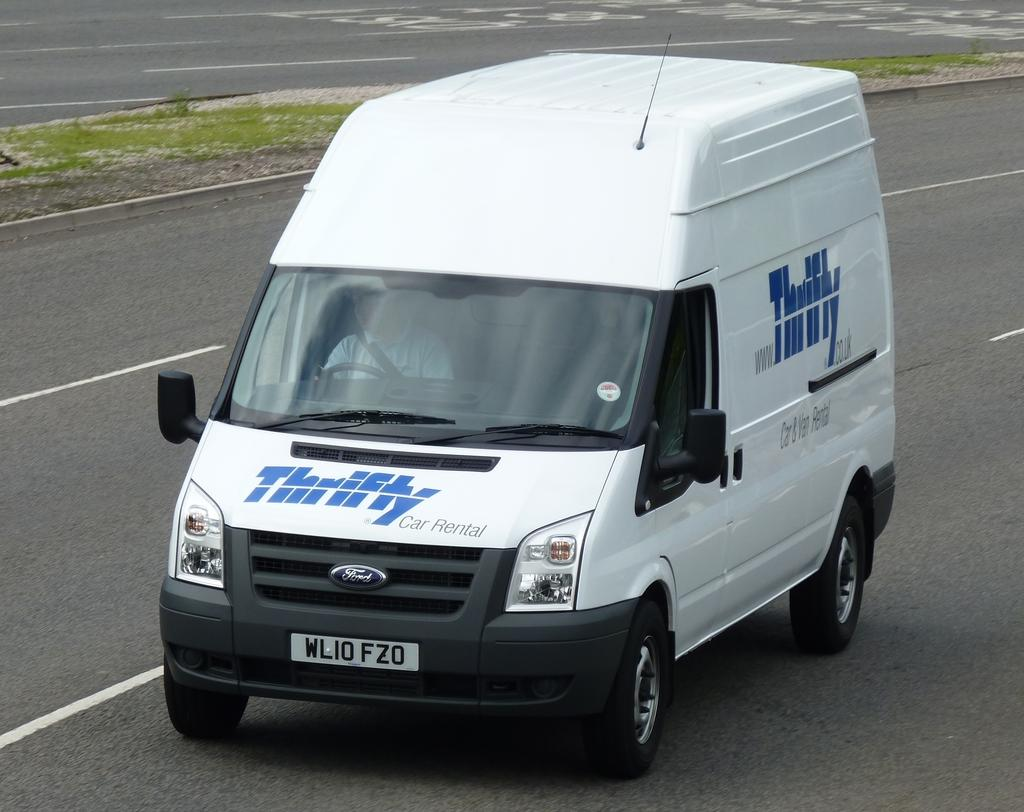Provide a one-sentence caption for the provided image. the word thrifty that is on a van. 